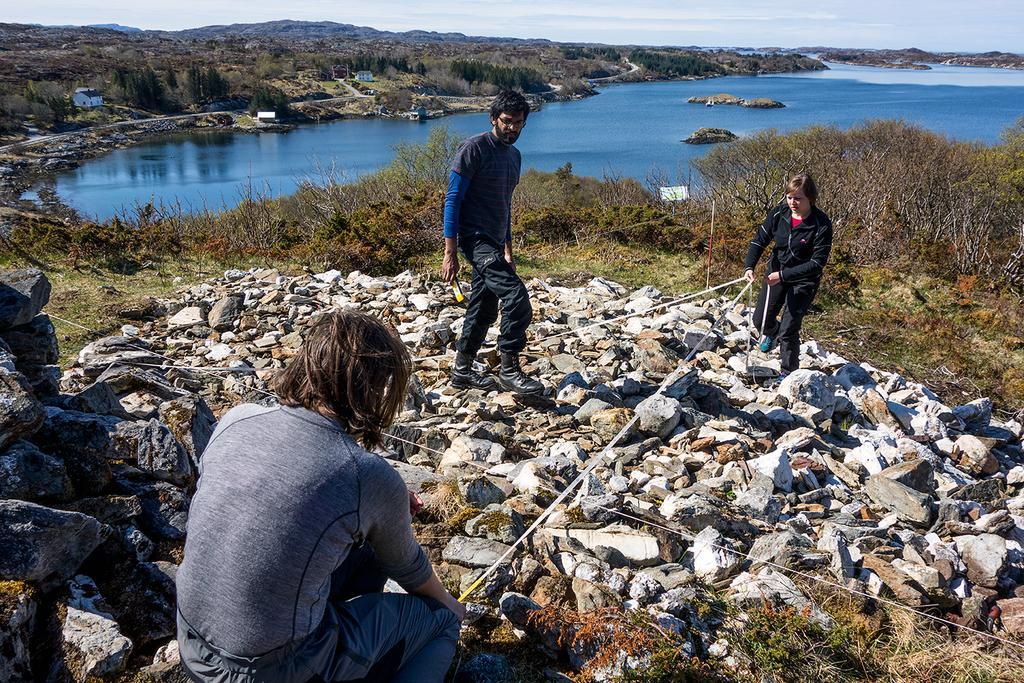In one or two sentences, can you explain what this image depicts? In this image, we can see persons wearing clothes. There are some plants and rocks in the middle of the image. There is a lake at the top of the image. 